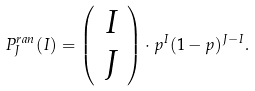<formula> <loc_0><loc_0><loc_500><loc_500>P ^ { r a n } _ { J } ( I ) = \left ( \begin{array} { c } I \\ J \end{array} \right ) \cdot p ^ { I } ( 1 - p ) ^ { J - I } .</formula> 